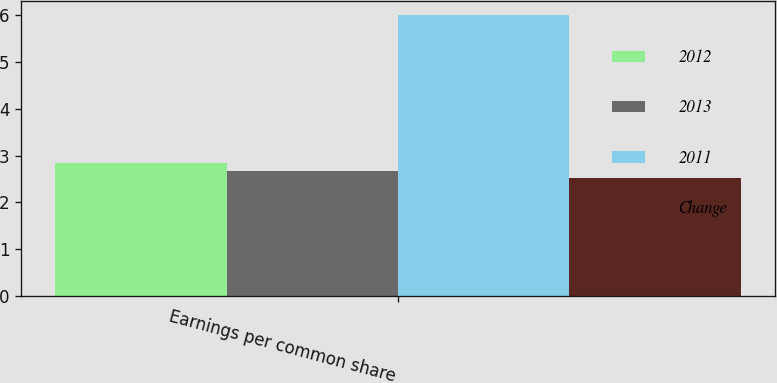<chart> <loc_0><loc_0><loc_500><loc_500><stacked_bar_chart><ecel><fcel>Earnings per common share<nl><fcel>2012<fcel>2.84<nl><fcel>2013<fcel>2.68<nl><fcel>2011<fcel>6<nl><fcel>Change<fcel>2.51<nl></chart> 